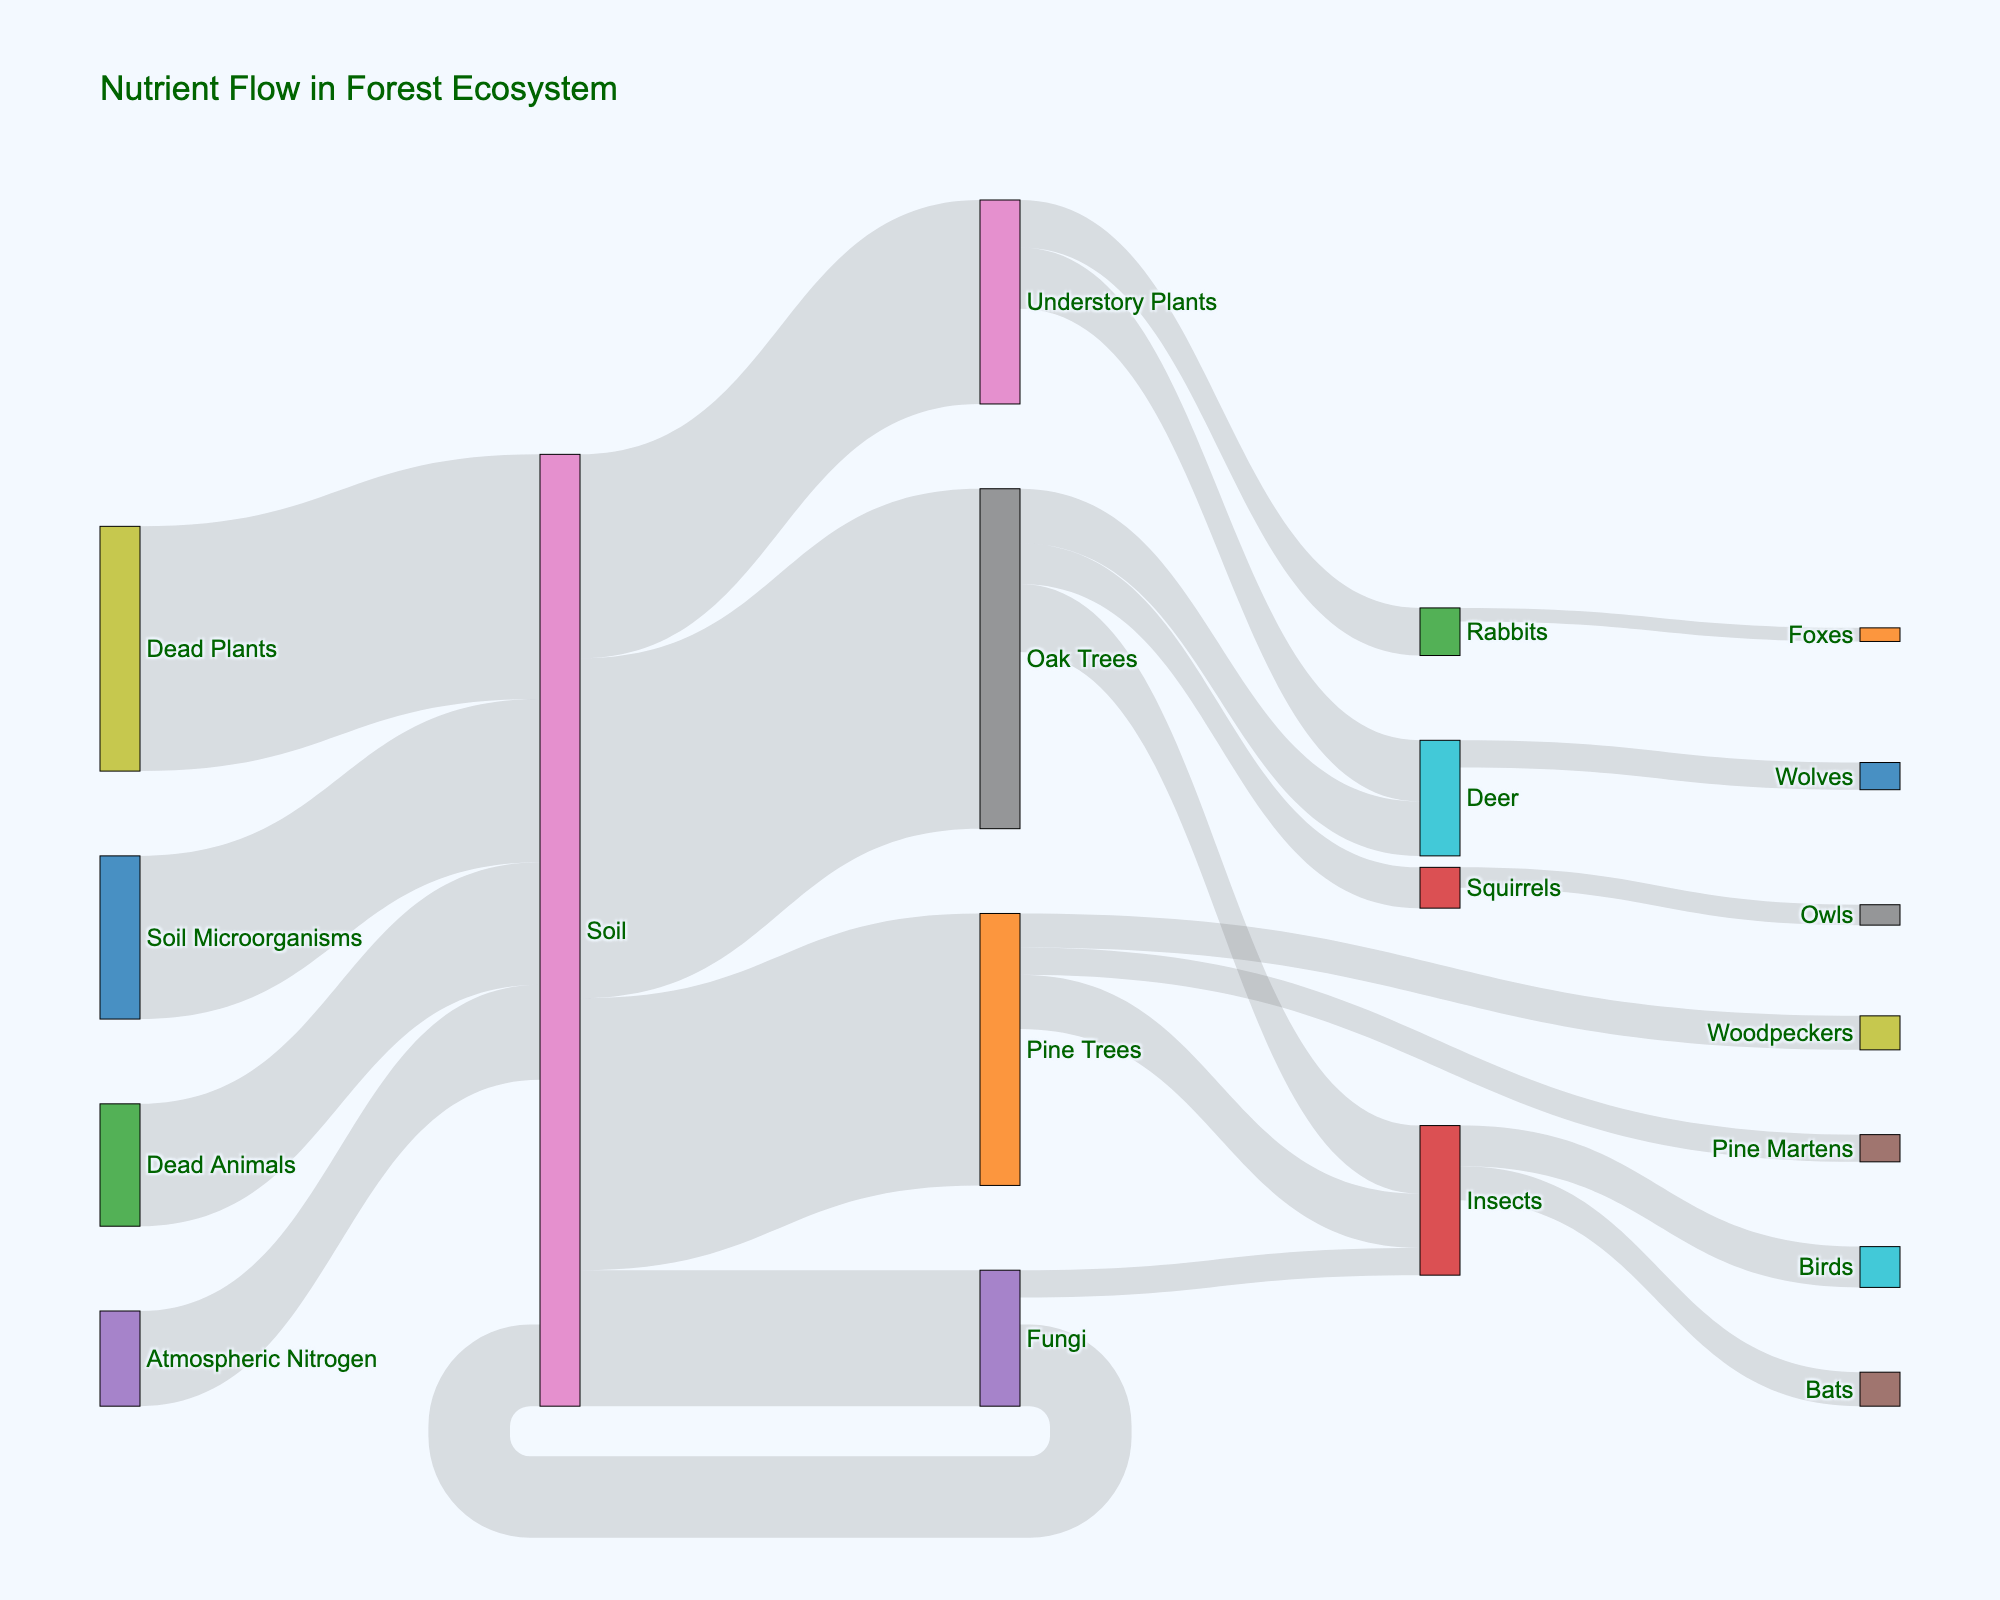What is the title of the Sankey Diagram? The title is typically displayed at the top of the plot and summarizes the diagram's theme.
Answer: Nutrient Flow in Forest Ecosystem What are the main nutrient sources in the forest ecosystem according to the diagram? Identify the nodes from which the nutrient flows originate. These are the first nodes in the list of sources.
Answer: Soil, Atmospheric Nitrogen, Soil Microorganisms Which plant species receive the most nutrients from the soil? Compare the values of nutrient flow from the soil to different plant species.
Answer: Oak Trees How much total nutrient flow is returned to the soil? Sum the nutrient values of dead plants, dead animals, and fungi returning to the soil. 180 + 90 + 60
Answer: 330 Compare the nutrient flow to insects from oak trees and pine trees. Which trees contribute more? Identify nutrient flows from oak trees and pine trees to insects, then compare the values (50 and 40, respectively).
Answer: Oak Trees How does the nutrient flow from rabbits to foxes compare with squirrels to owls? Identify and compare the nutrient values between these pairs. (10 vs. 15, respectively).
Answer: Squirrels to owls Which animal species is directly receiving nutrients from both plants and fungi? Look for overlapping targets between plant species and fungi flows.
Answer: Insects What is the total nutrient flow going to deer? Sum the nutrient values from oak trees and understory plants to deer. 40 + 45
Answer: 85 Which has a higher nutrient flow: the contribution of atmospheric nitrogen to the soil or the sum of the flows from soil microorganisms to the soil? Compare the nutrient flows of these two sources, which are 70 and 120, respectively.
Answer: Soil Microorganisms What is the total nutrient flow entering the insects? Sum the nutrient values from oak trees, pine trees, and fungi that flow into insects. 50 + 40 + 20
Answer: 110 